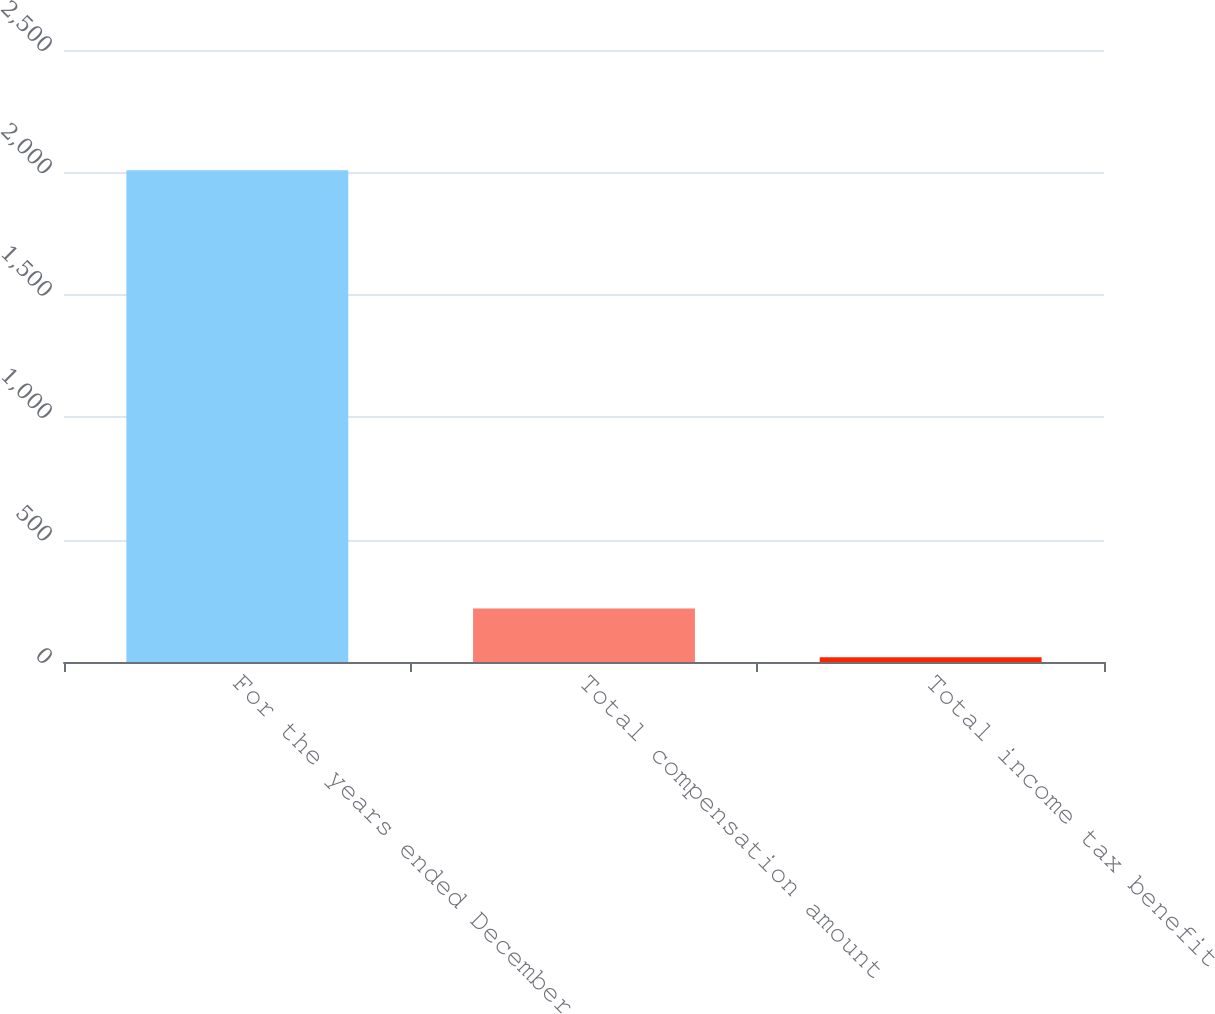Convert chart. <chart><loc_0><loc_0><loc_500><loc_500><bar_chart><fcel>For the years ended December<fcel>Total compensation amount<fcel>Total income tax benefit<nl><fcel>2009<fcel>218.09<fcel>19.1<nl></chart> 